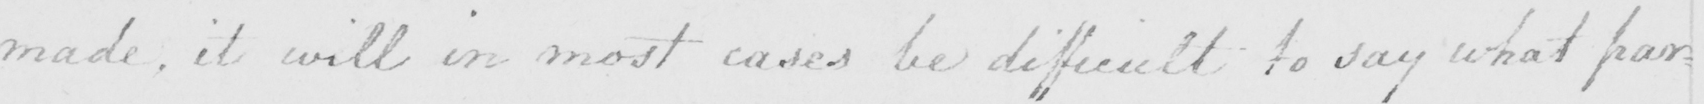Can you read and transcribe this handwriting? made , it will in most cases be difficult to say what par= 